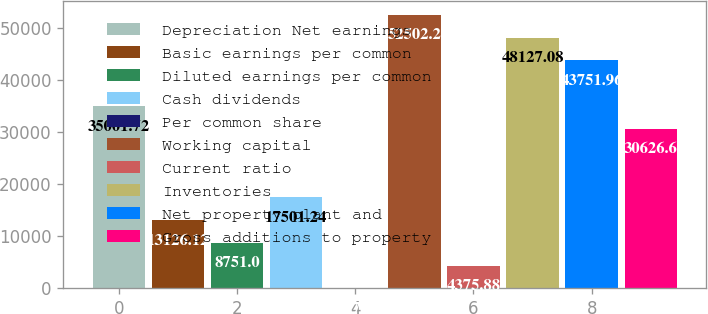<chart> <loc_0><loc_0><loc_500><loc_500><bar_chart><fcel>Depreciation Net earnings<fcel>Basic earnings per common<fcel>Diluted earnings per common<fcel>Cash dividends<fcel>Per common share<fcel>Working capital<fcel>Current ratio<fcel>Inventories<fcel>Net property plant and<fcel>Gross additions to property<nl><fcel>35001.7<fcel>13126.1<fcel>8751<fcel>17501.2<fcel>0.76<fcel>52502.2<fcel>4375.88<fcel>48127.1<fcel>43752<fcel>30626.6<nl></chart> 